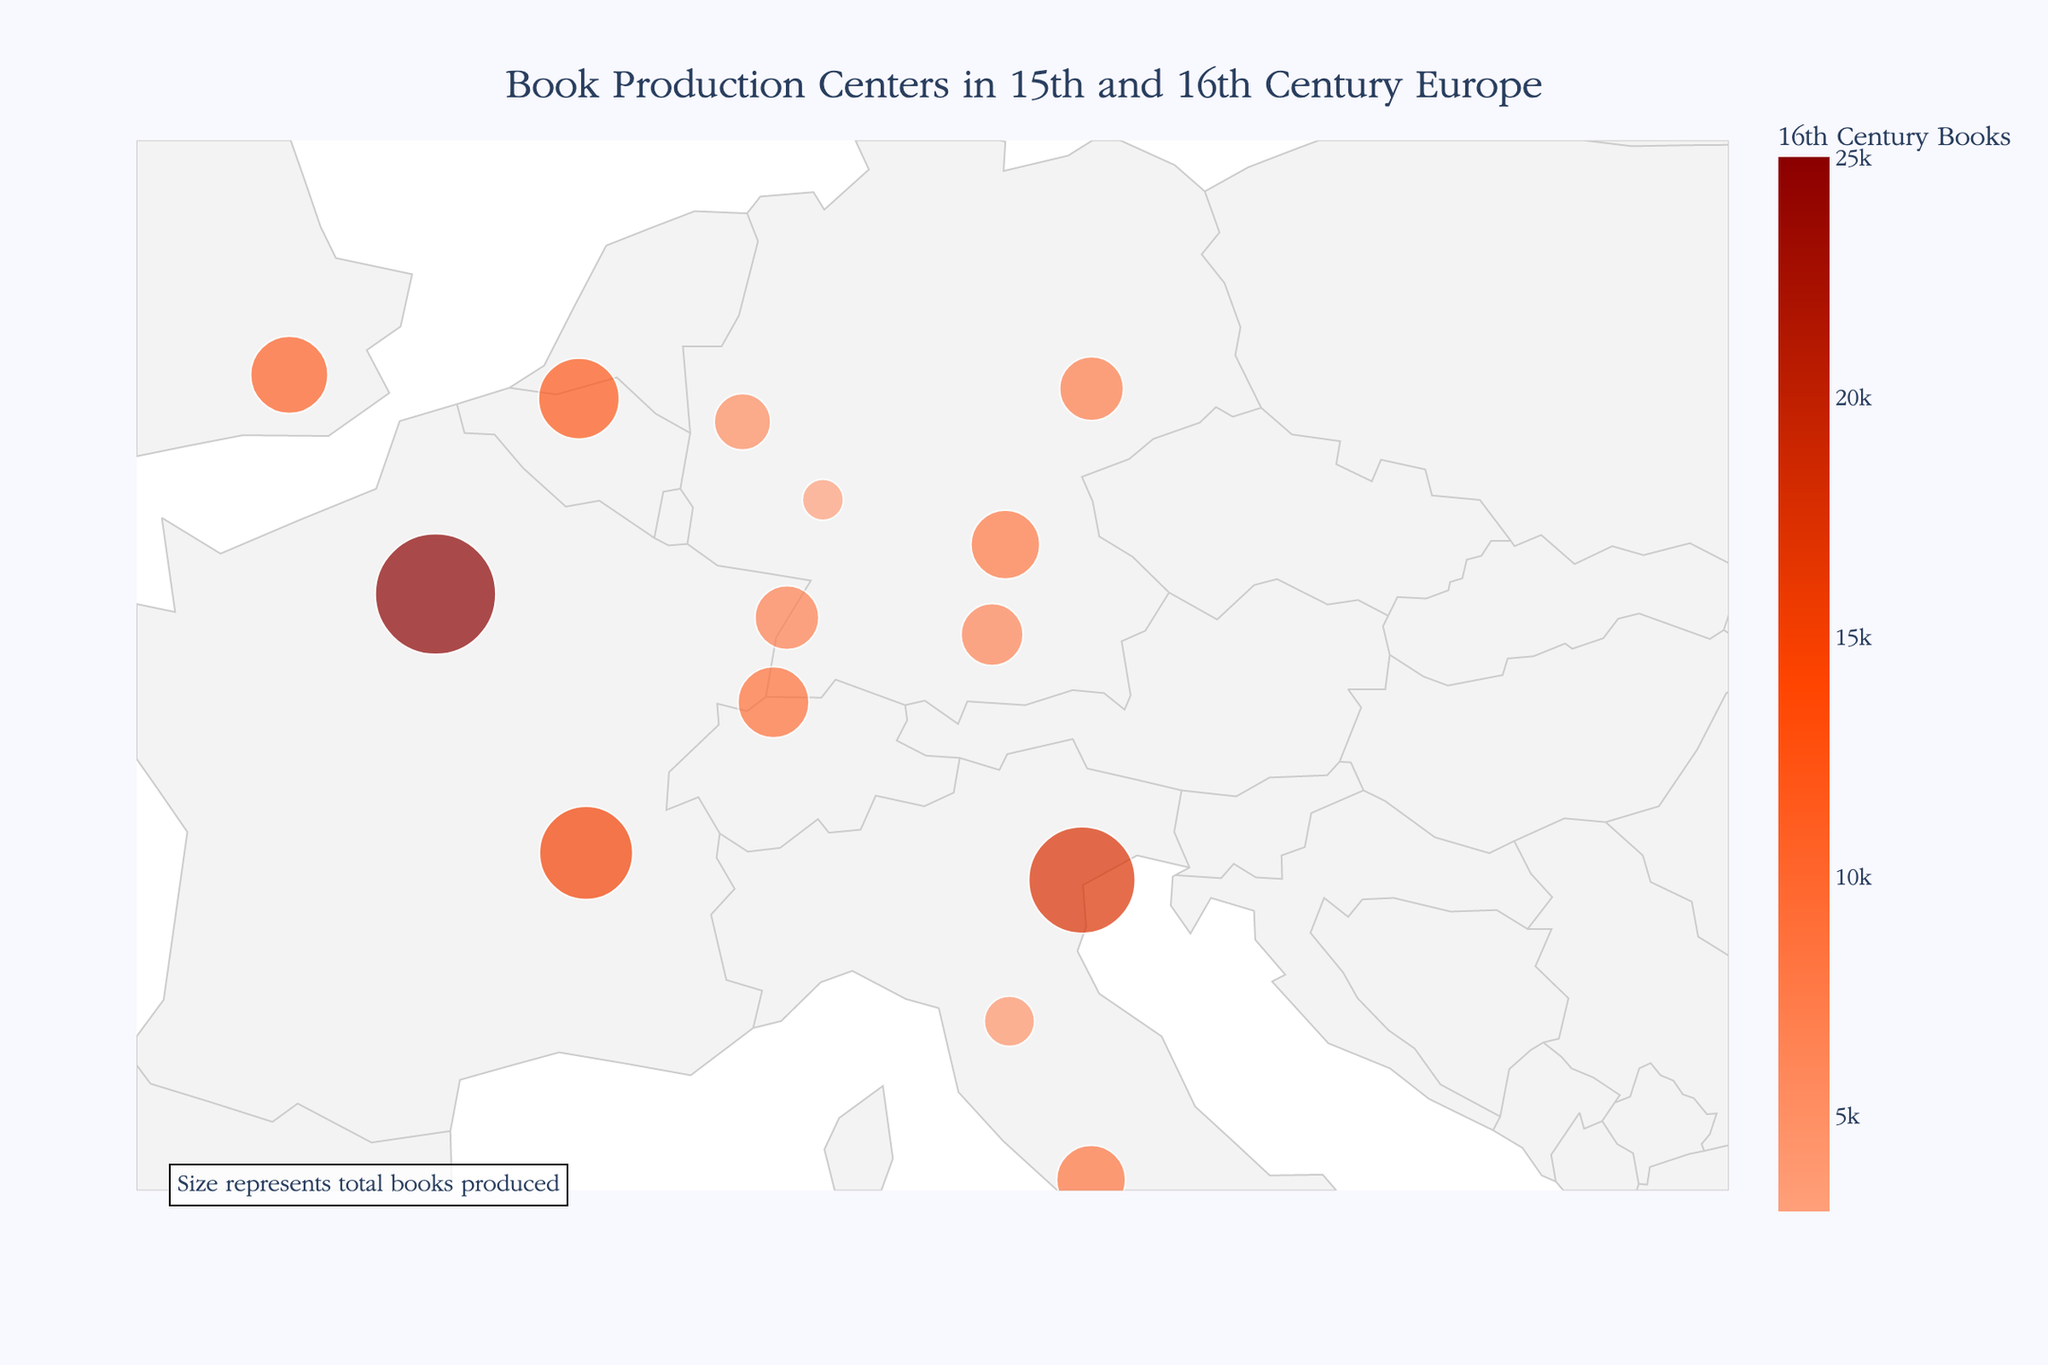Which city produced the most books in the 16th century? Observing the color of the data points as darker shades represent more books. Paris's marker is the darkest shade. Checking the hover data will confirm this.
Answer: Paris What is the combined total of books produced by Venice in the 15th and 16th centuries? Look at Venice's total book production size and sum the 15th and 16th-century numbers. Hovering over Venice shows 4000 for the 15th century and 17500 for the 16th century, thus 4000 + 17500.
Answer: 21500 Which country has the highest number of significant book production centers? Count the number of data points in each country; France has three: Paris, Lyon, and Strasbourg.
Answer: France How does the total book production in Rome compare to that in London for the 16th century? Hover over Rome and London to see their 16th-century production. Rome has 8500, while London has 11000. Compare the two values next.
Answer: London is higher Which city shows the largest increase in book production from the 15th to the 16th century? Inspect the hover data to calculate the difference in book production for all cities. Paris goes from 2500 to 25000, an increase of 22500. This is the highest among all listed.
Answer: Paris What are the geographical coordinates of the city with the fewest books produced in the 15th century? By checking the smallest markers and their hover information, Seville produced 150 books. Its coordinates are visible: 37.3891 latitude and -5.9845 longitude.
Answer: 37.3891, -5.9845 What is the average number of books produced in the 16th century by cities in Germany? Identify German cities (Nuremberg, Augsburg, Cologne, Leipzig, Mainz), sum their 16th-century production (8000 + 6500 + 5500 + 7500 + 3000 = 30500), and divide by the number of cities (5).
Answer: 6100 Which city in Italy, apart from Venice, produced a significant number of books, and how many in the 16th century? Italy includes Venice, Rome, and Florence. Exclude Venice. Rome produced 8500, and Florence produced 4500.
Answer: Rome, 8500 What distinguishes the book production pattern between the 15th and 16th centuries in Antwerp? Observing Antwerp, its size marker is smaller for the 15th century (400) and substantially larger for the 16th century (12000), indicating a major production increase.
Answer: Substantial increase 